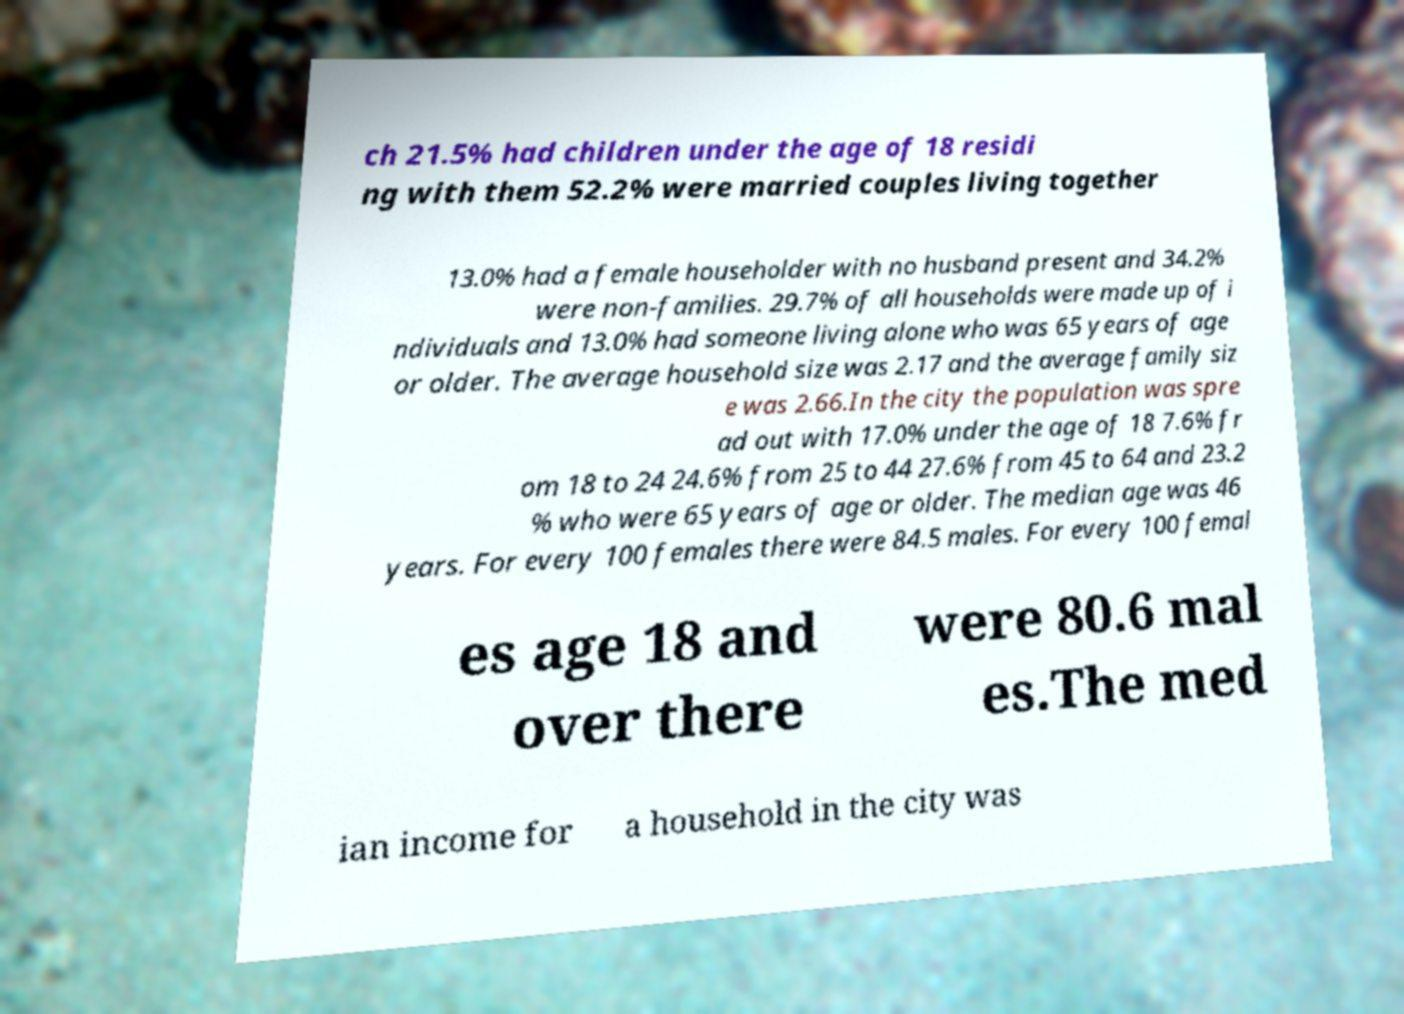What messages or text are displayed in this image? I need them in a readable, typed format. ch 21.5% had children under the age of 18 residi ng with them 52.2% were married couples living together 13.0% had a female householder with no husband present and 34.2% were non-families. 29.7% of all households were made up of i ndividuals and 13.0% had someone living alone who was 65 years of age or older. The average household size was 2.17 and the average family siz e was 2.66.In the city the population was spre ad out with 17.0% under the age of 18 7.6% fr om 18 to 24 24.6% from 25 to 44 27.6% from 45 to 64 and 23.2 % who were 65 years of age or older. The median age was 46 years. For every 100 females there were 84.5 males. For every 100 femal es age 18 and over there were 80.6 mal es.The med ian income for a household in the city was 